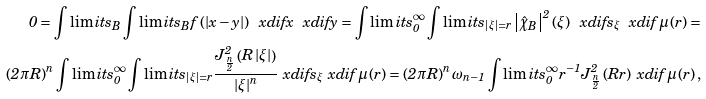Convert formula to latex. <formula><loc_0><loc_0><loc_500><loc_500>0 = \int \lim i t s _ { B } \int \lim i t s _ { B } f \left ( \left | x - y \right | \right ) \ x d i f x \ x d i f y = \int \lim i t s _ { 0 } ^ { \infty } \int \lim i t s _ { \left | \xi \right | = r } \left | \hat { \chi } _ { B } \right | ^ { 2 } \left ( \xi \right ) \ x d i f s _ { \xi } \ x d i f \mu \left ( r \right ) = \\ \left ( 2 \pi R \right ) ^ { n } \int \lim i t s _ { 0 } ^ { \infty } \int \lim i t s _ { \left | \xi \right | = r } \frac { J _ { \frac { n } { 2 } } ^ { 2 } \left ( R \left | \xi \right | \right ) } { \left | \xi \right | ^ { n } } \ x d i f s _ { \xi } \ x d i f \mu \left ( r \right ) = \left ( 2 \pi R \right ) ^ { n } \omega _ { n - 1 } \int \lim i t s _ { 0 } ^ { \infty } r ^ { - 1 } J _ { \frac { n } { 2 } } ^ { 2 } \left ( R r \right ) \ x d i f \mu \left ( r \right ) ,</formula> 